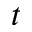<formula> <loc_0><loc_0><loc_500><loc_500>t</formula> 